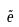<formula> <loc_0><loc_0><loc_500><loc_500>\tilde { e }</formula> 